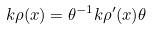Convert formula to latex. <formula><loc_0><loc_0><loc_500><loc_500>k \rho ( x ) = \theta ^ { - 1 } k \rho ^ { \prime } ( x ) \theta</formula> 